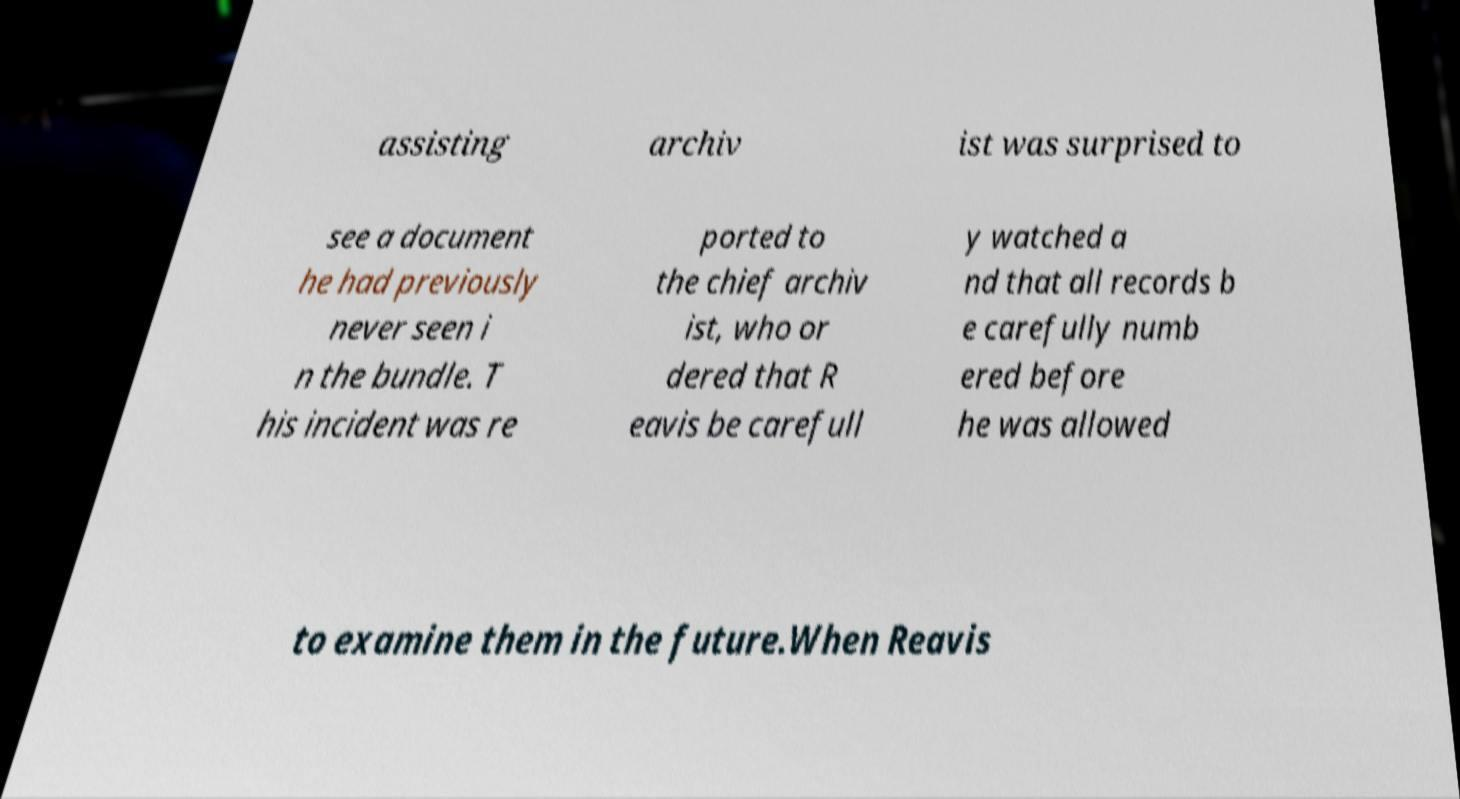Can you accurately transcribe the text from the provided image for me? assisting archiv ist was surprised to see a document he had previously never seen i n the bundle. T his incident was re ported to the chief archiv ist, who or dered that R eavis be carefull y watched a nd that all records b e carefully numb ered before he was allowed to examine them in the future.When Reavis 